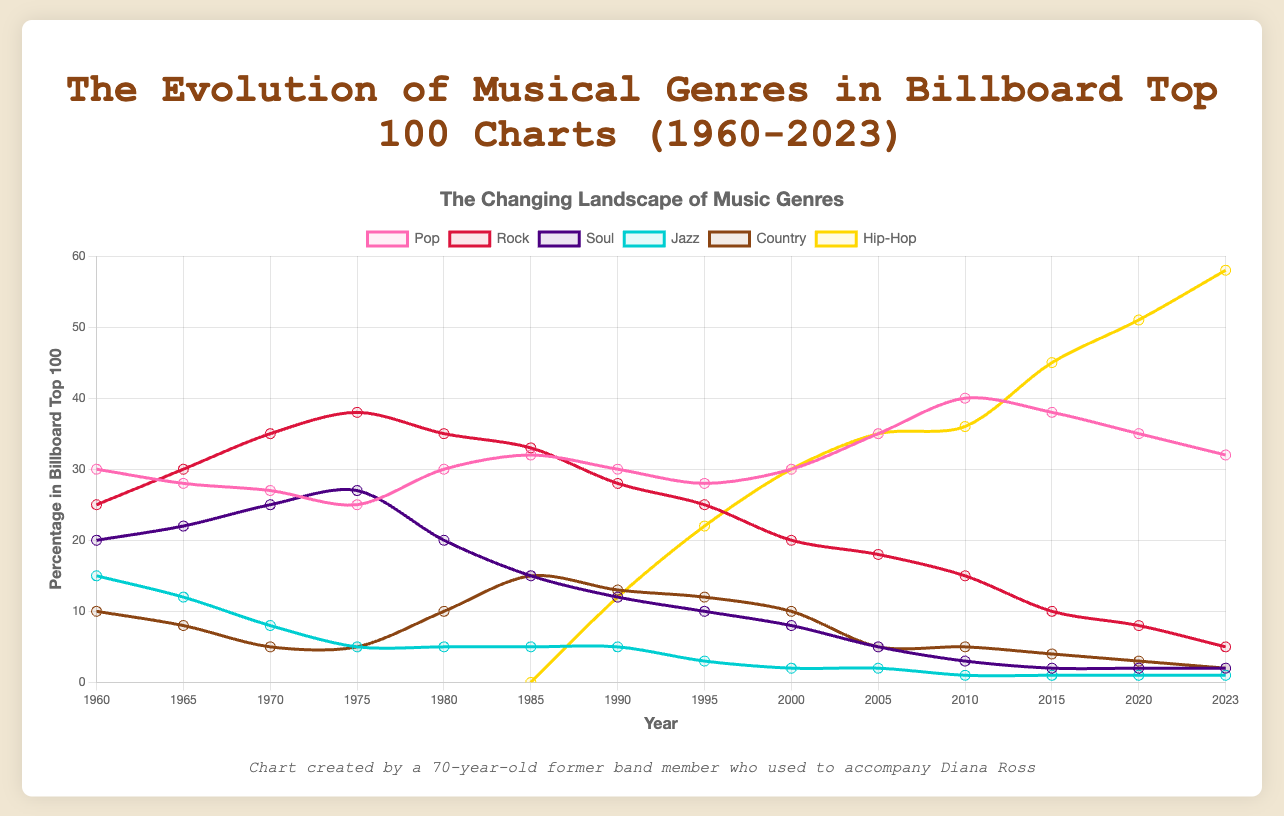Which musical genre had the highest percentage in the Billboard Top 100 in 2023? Look at the data for 2023 and identify the genre with the highest percentage. Hip-Hop leads with 58%.
Answer: Hip-Hop In which year did Jazz see its steepest decline? From 1960 to 2023, observe the year-to-year changes in the Jazz percentage. The largest drop occurs between 1970 and 1975, going from 8% to 5%.
Answer: 1970-1975 What is the average percentage of Soul music present in the Billboard Top 100 from 1960 to 2023? Add the percentages of Soul from 1960 to 2023 (total 176) and divide by the number of years (14). (20+22+25+27+20+15+12+10+8+5+3+2+2+2)/14 = 12.571.
Answer: 12.571 Which genre has shown the most consistent percentage (least fluctuation) over the years? Examine each genre's data from 1960 to 2023 and calculate the variance. Jazz shows the least fluctuation, consistently staying low.
Answer: Jazz How did the percentage of Country music change from 1985 to 1990? Look at the values for Country in 1985 and 1990. The percentage decreased from 15% in 1985 to 13% in 1990.
Answer: Decreased by 2% Which genre experienced the largest growth in percentage from 1985 to 2000? Compare the percentage increase for each genre between 1985 and 2000. Hip-Hop grew from 0% in 1985 to 30% in 2000, the largest increase of 30%.
Answer: Hip-Hop What trend do you notice for Rock music from 1960 to 2023? Analyze the percentage of Rock throughout the years—Rock peaked around 1975 and shows a steady decline thereafter, reaching the lowest in 2023 at 5%.
Answer: Steady decline What is the difference in the percentage of Pop music between 2010 and 2023? Subtract the Pop percentage in 2023 from that in 2010. The difference is 40% in 2010 and 32% in 2023, which is 8%.
Answer: 8% Which year shows Hip-Hop overtaking Pop in percentage for the first time? Look for the year where Hip-Hop's percentage first exceeds Pop. This occurs in 2005 with Hip-Hop at 35% and Pop at 35% (tie), but Hip-Hop significantly surpasses Pop in 2015.
Answer: 2015 By how much did the percentage of Rock music change from its highest point to 2023? Identify Rock's highest percentage (38% in 1975) and its percentage in 2023 (5%), then calculate the difference: 38% - 5% = 33%.
Answer: 33% 